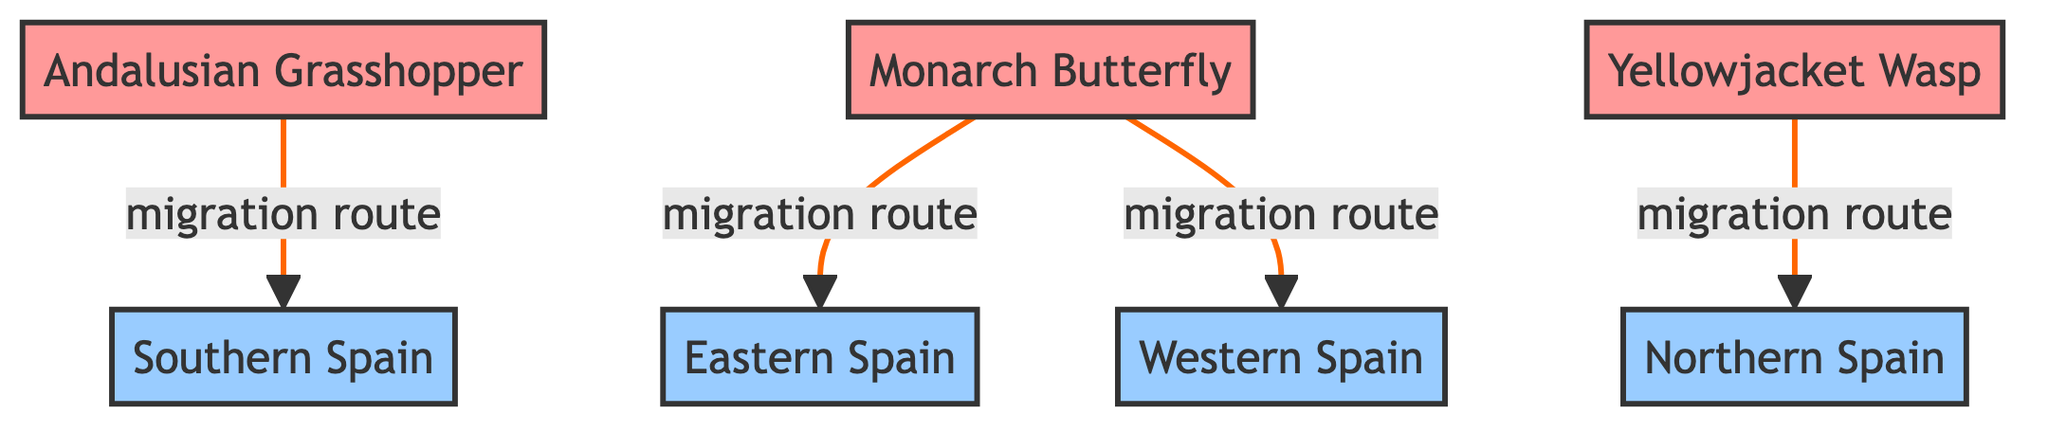What species migrates to Southern Spain? The diagram shows that the Andalusian Grasshopper has a migration route leading to Southern Spain. Therefore, it is the species that migrates to that region.
Answer: Andalusian Grasshopper How many species are shown in the diagram? By counting the nodes designated as species, we find three: Andalusian Grasshopper, Monarch Butterfly, and Yellowjacket Wasp.
Answer: 3 Which region does the Monarch Butterfly migrate to first? The edges from the Monarch Butterfly indicate it has migration routes to both Eastern and Western Spain. Therefore, the first region it migrates to is Eastern Spain.
Answer: Eastern Spain What is the migration route of the Yellowjacket Wasp? The diagram clearly shows that the Yellowjacket Wasp has one migration route going to Northern Spain. This indicates its migration connection.
Answer: Northern Spain How many migration routes are illustrated in the diagram? Counting the edges in the diagram reveals there are four migration routes represented.
Answer: 4 Which species have migration routes leading to Western Spain? The diagram indicates that only the Monarch Butterfly has a migration route that leads to Western Spain. Therefore, it is the sole species with that connection.
Answer: Monarch Butterfly Which region is connected to the Andalusian Grasshopper? The chart directs that the Andalusian Grasshopper has a migration route connecting it to Southern Spain. Thus, it highlights its relationship with that region.
Answer: Southern Spain What type of diagram is being represented? The characteristics of the diagram reveal it is a network diagram, showcasing relationships and migration routes among species and regions.
Answer: Network Diagram What are the endpoints of the migration route for the Monarch Butterfly? The diagram lists two endpoints for the migration route of the Monarch Butterfly: Eastern Spain and Western Spain. Therefore, these are its target regions.
Answer: Eastern Spain, Western Spain 